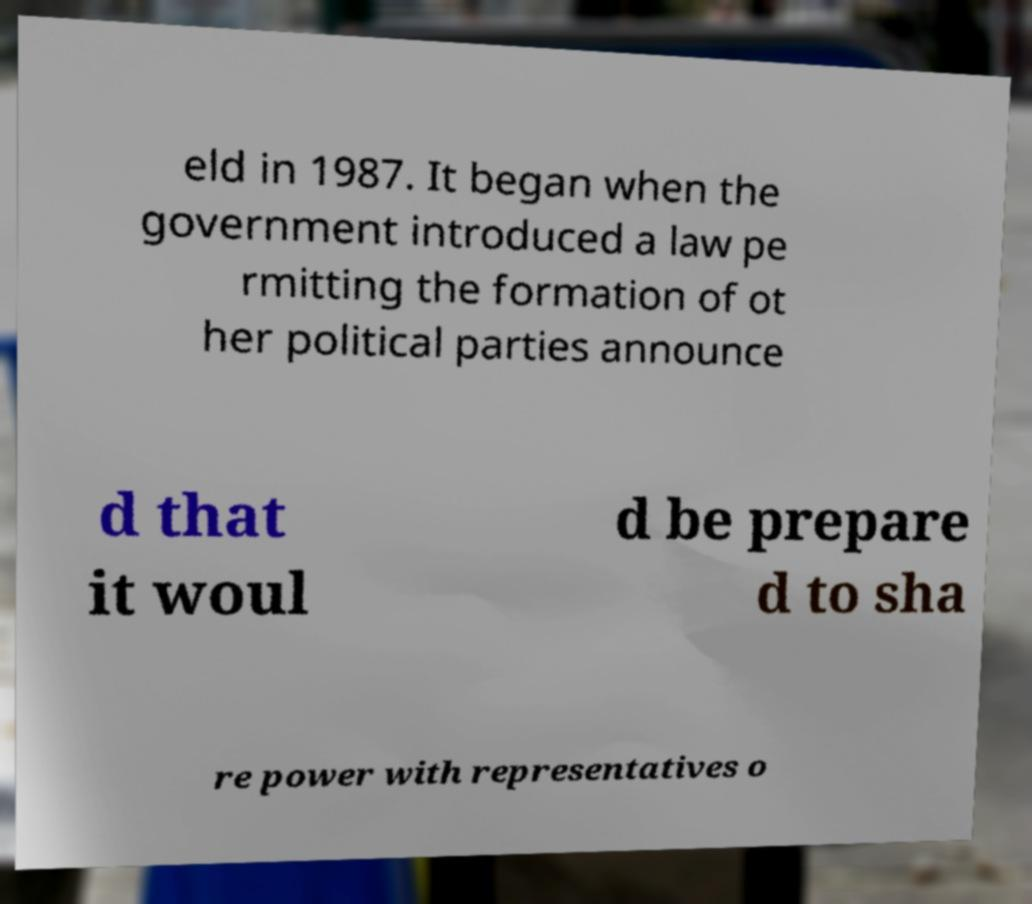There's text embedded in this image that I need extracted. Can you transcribe it verbatim? eld in 1987. It began when the government introduced a law pe rmitting the formation of ot her political parties announce d that it woul d be prepare d to sha re power with representatives o 